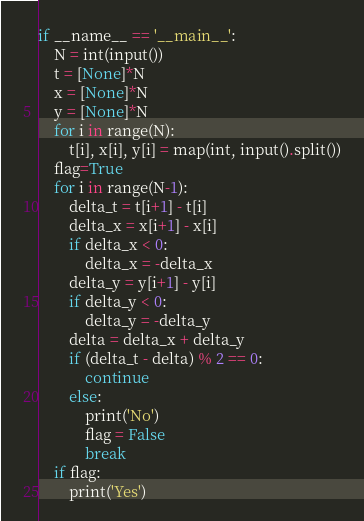<code> <loc_0><loc_0><loc_500><loc_500><_Python_>if __name__ == '__main__':
    N = int(input())
    t = [None]*N
    x = [None]*N
    y = [None]*N
    for i in range(N):
        t[i], x[i], y[i] = map(int, input().split())
    flag=True
    for i in range(N-1):
        delta_t = t[i+1] - t[i]
        delta_x = x[i+1] - x[i]
        if delta_x < 0:
            delta_x = -delta_x
        delta_y = y[i+1] - y[i]
        if delta_y < 0:
            delta_y = -delta_y
        delta = delta_x + delta_y
        if (delta_t - delta) % 2 == 0:
            continue
        else:
            print('No')
            flag = False
            break
    if flag:
        print('Yes')</code> 